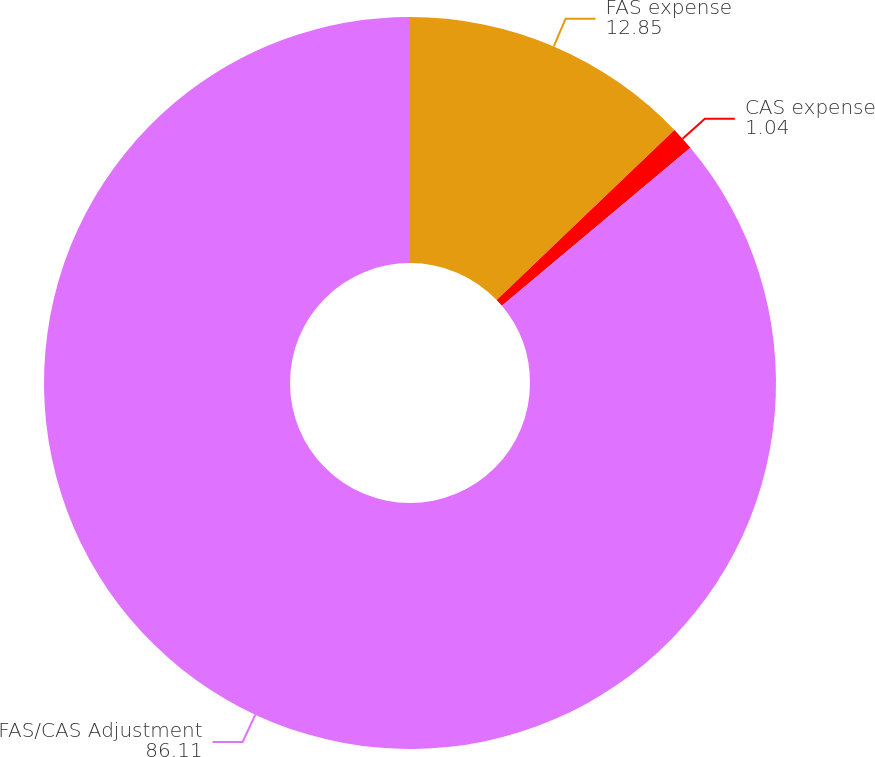Convert chart. <chart><loc_0><loc_0><loc_500><loc_500><pie_chart><fcel>FAS expense<fcel>CAS expense<fcel>FAS/CAS Adjustment<nl><fcel>12.85%<fcel>1.04%<fcel>86.11%<nl></chart> 